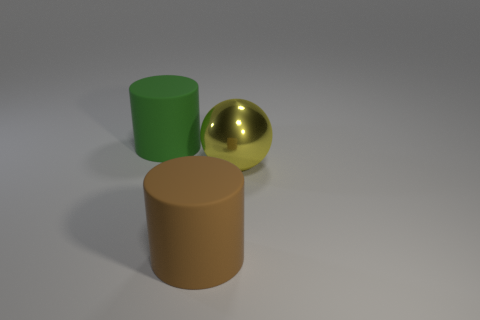What material is the large brown object that is in front of the shiny ball?
Provide a succinct answer. Rubber. Are there an equal number of large objects that are on the right side of the yellow shiny thing and brown rubber cylinders that are in front of the brown matte cylinder?
Provide a succinct answer. Yes. Is the size of the thing behind the yellow thing the same as the matte thing that is in front of the green rubber object?
Your response must be concise. Yes. What number of matte cylinders have the same color as the big metal sphere?
Your response must be concise. 0. Is the number of green objects in front of the brown matte object greater than the number of red metal spheres?
Provide a succinct answer. No. Is the shape of the green thing the same as the big brown matte object?
Your response must be concise. Yes. How many big brown cylinders are made of the same material as the big green cylinder?
Your answer should be compact. 1. What size is the other thing that is the same shape as the large green object?
Your response must be concise. Large. Is the size of the brown thing the same as the sphere?
Provide a succinct answer. Yes. What shape is the rubber object that is in front of the object that is on the left side of the large matte thing in front of the big green cylinder?
Your answer should be compact. Cylinder. 